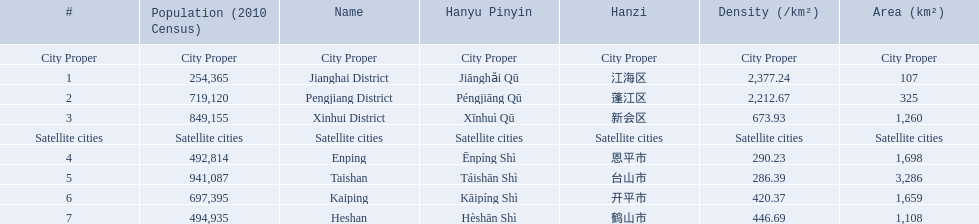What cities are there in jiangmen? Jianghai District, Pengjiang District, Xinhui District, Enping, Taishan, Kaiping, Heshan. Of those, which ones are a city proper? Jianghai District, Pengjiang District, Xinhui District. Of those, which one has the smallest area in km2? Jianghai District. 